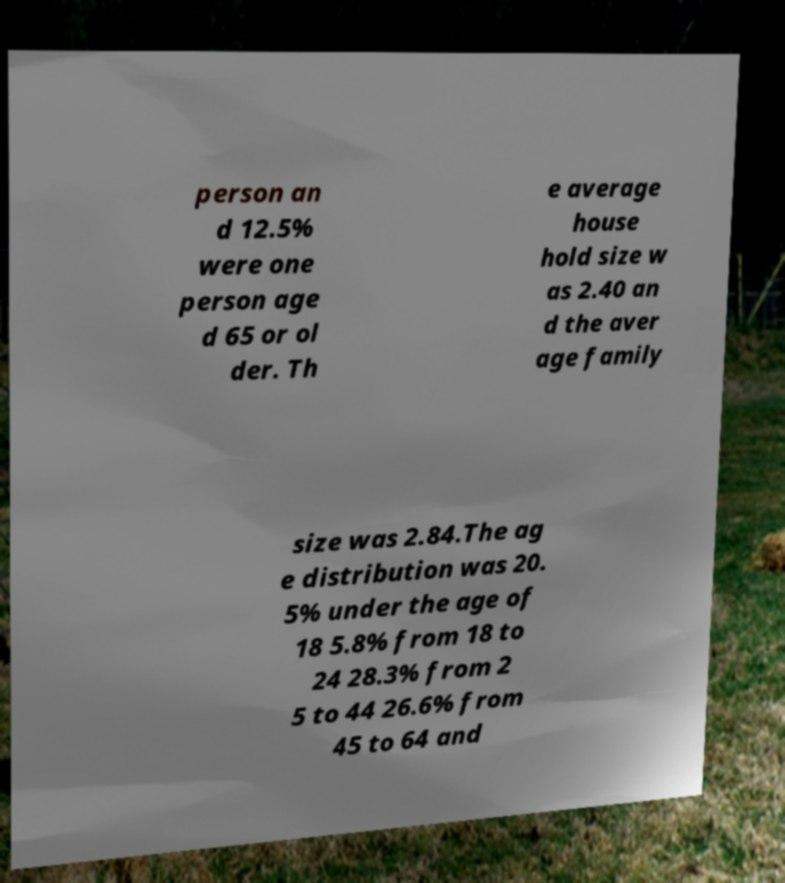Could you extract and type out the text from this image? person an d 12.5% were one person age d 65 or ol der. Th e average house hold size w as 2.40 an d the aver age family size was 2.84.The ag e distribution was 20. 5% under the age of 18 5.8% from 18 to 24 28.3% from 2 5 to 44 26.6% from 45 to 64 and 